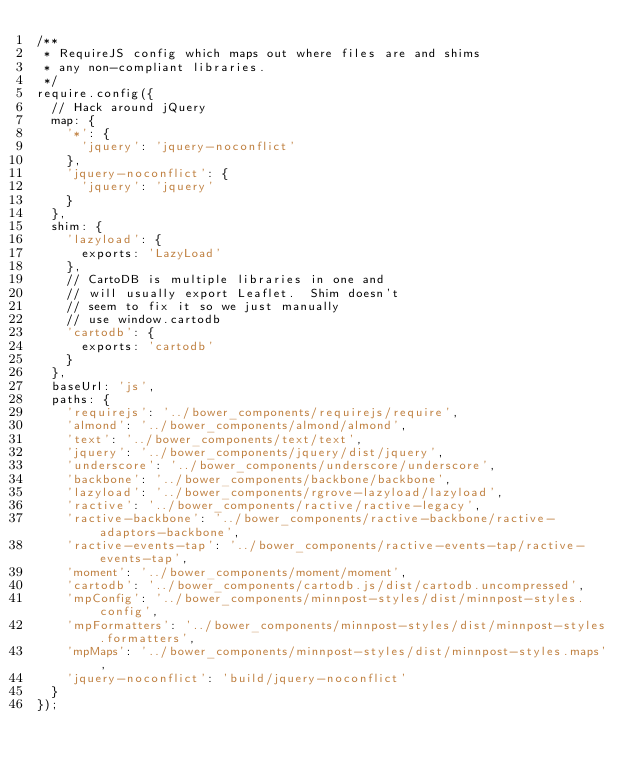<code> <loc_0><loc_0><loc_500><loc_500><_JavaScript_>/**
 * RequireJS config which maps out where files are and shims
 * any non-compliant libraries.
 */
require.config({
  // Hack around jQuery
  map: {
    '*': {
      'jquery': 'jquery-noconflict'
    },
    'jquery-noconflict': {
      'jquery': 'jquery'
    }
  },
  shim: {
    'lazyload': {
      exports: 'LazyLoad'
    },
    // CartoDB is multiple libraries in one and
    // will usually export Leaflet.  Shim doesn't
    // seem to fix it so we just manually
    // use window.cartodb
    'cartodb': {
      exports: 'cartodb'
    }
  },
  baseUrl: 'js',
  paths: {
    'requirejs': '../bower_components/requirejs/require',
    'almond': '../bower_components/almond/almond',
    'text': '../bower_components/text/text',
    'jquery': '../bower_components/jquery/dist/jquery',
    'underscore': '../bower_components/underscore/underscore',
    'backbone': '../bower_components/backbone/backbone',
    'lazyload': '../bower_components/rgrove-lazyload/lazyload',
    'ractive': '../bower_components/ractive/ractive-legacy',
    'ractive-backbone': '../bower_components/ractive-backbone/ractive-adaptors-backbone',
    'ractive-events-tap': '../bower_components/ractive-events-tap/ractive-events-tap',
    'moment': '../bower_components/moment/moment',
    'cartodb': '../bower_components/cartodb.js/dist/cartodb.uncompressed',
    'mpConfig': '../bower_components/minnpost-styles/dist/minnpost-styles.config',
    'mpFormatters': '../bower_components/minnpost-styles/dist/minnpost-styles.formatters',
    'mpMaps': '../bower_components/minnpost-styles/dist/minnpost-styles.maps',
    'jquery-noconflict': 'build/jquery-noconflict'
  }
});
</code> 